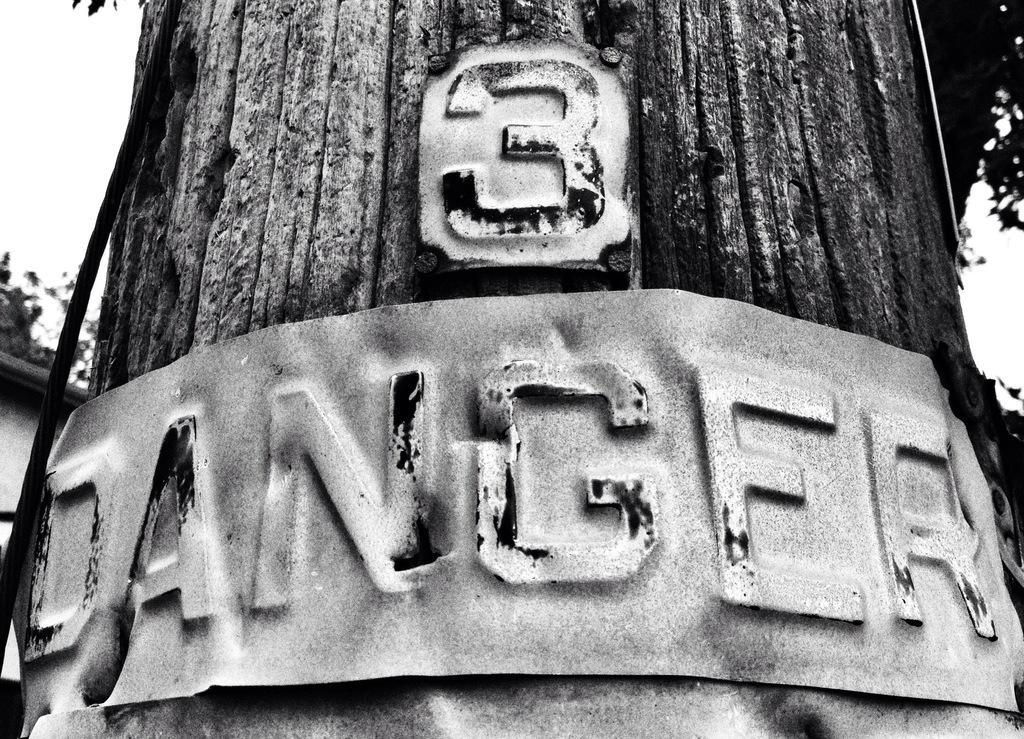Can you describe this image briefly? In this picture we can see an old photograph of the tree trunk. In the front there is a iron plate stick to it, on which "dangerous" is written. 